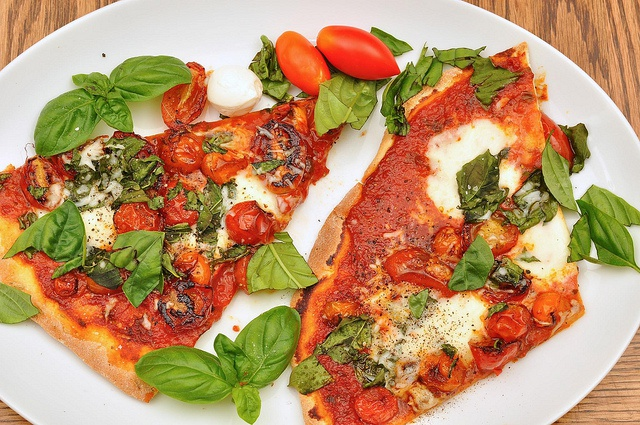Describe the objects in this image and their specific colors. I can see pizza in tan, red, brown, orange, and beige tones, pizza in tan, brown, red, orange, and olive tones, dining table in tan, salmon, and brown tones, and dining table in tan and gray tones in this image. 